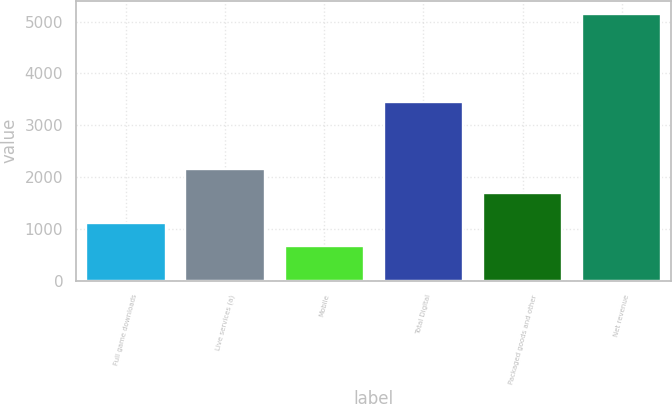Convert chart to OTSL. <chart><loc_0><loc_0><loc_500><loc_500><bar_chart><fcel>Full game downloads<fcel>Live services (a)<fcel>Mobile<fcel>Total Digital<fcel>Packaged goods and other<fcel>Net revenue<nl><fcel>1109<fcel>2149<fcel>660<fcel>3450<fcel>1700<fcel>5150<nl></chart> 